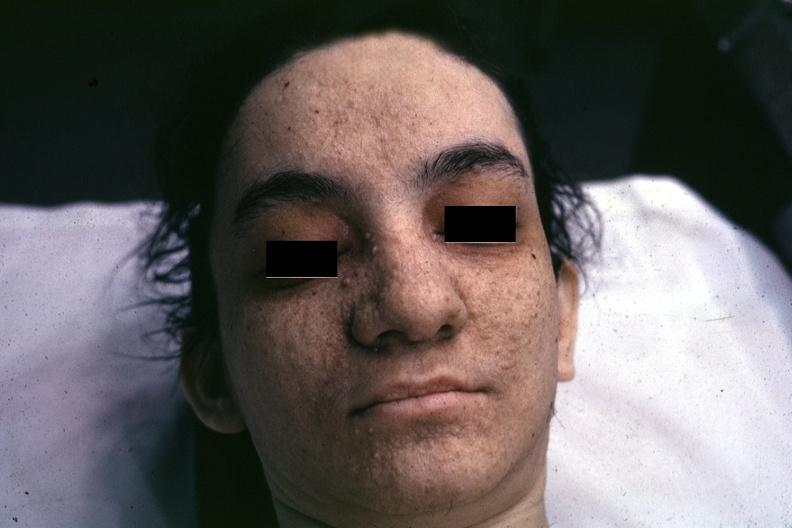s face present?
Answer the question using a single word or phrase. Yes 